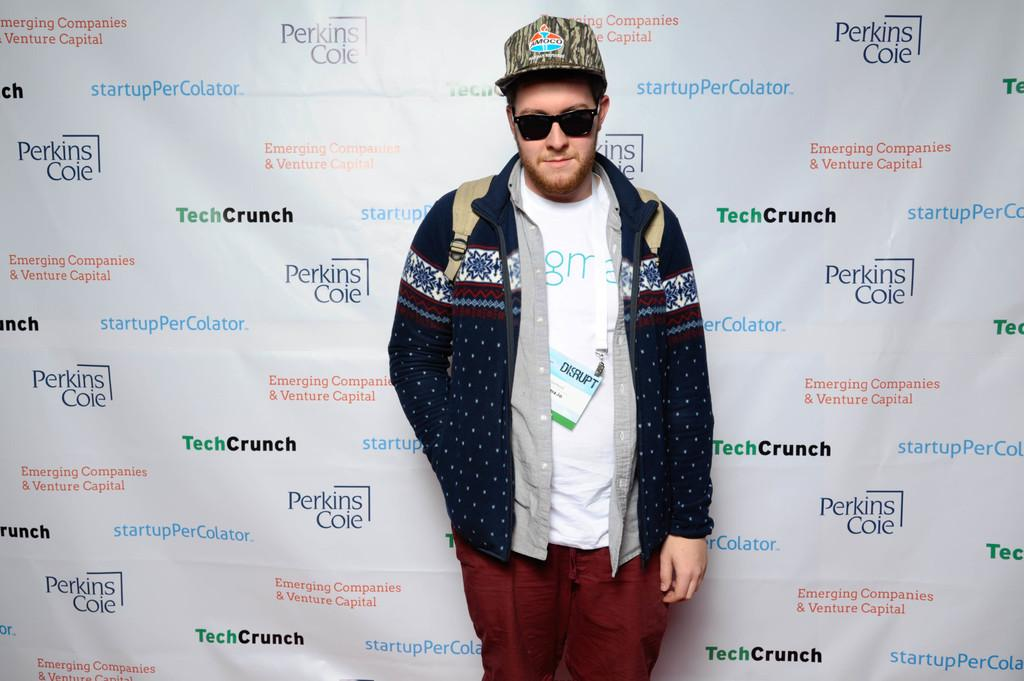What is the man in the image doing? The man is standing in the image. What accessories is the man wearing? The man is wearing a cap and sunglasses. What is the man carrying in the image? The man is carrying a backpack. What can be seen in the background of the image? There is a banner in the background of the image. What is written on the banner? The banner has some text on it. What type of picture is the man holding in his stomach in the image? There is no picture present in the image, and the man is not holding anything in his stomach. 